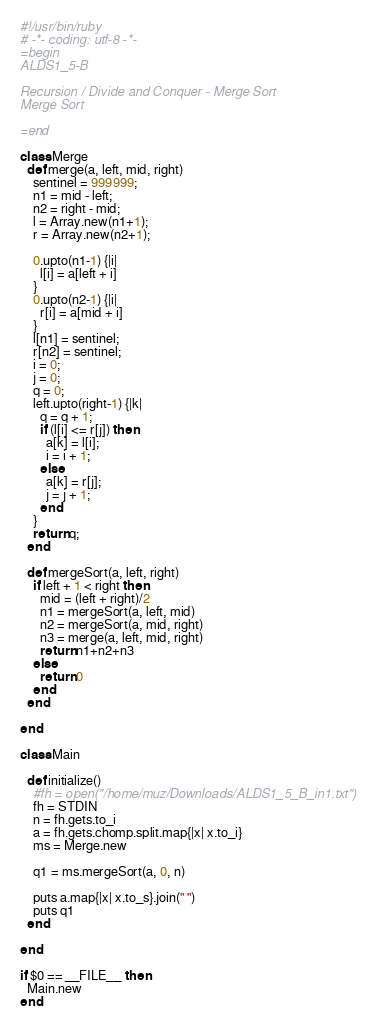Convert code to text. <code><loc_0><loc_0><loc_500><loc_500><_Ruby_>#!/usr/bin/ruby
# -*- coding: utf-8 -*-
=begin
ALDS1_5-B

Recursion / Divide and Conquer - Merge Sort
Merge Sort

=end

class Merge
  def merge(a, left, mid, right)
    sentinel = 999999;
    n1 = mid - left;
    n2 = right - mid;
    l = Array.new(n1+1);
    r = Array.new(n2+1);

    0.upto(n1-1) {|i|
      l[i] = a[left + i]
    }
    0.upto(n2-1) {|i|
      r[i] = a[mid + i]
    }
    l[n1] = sentinel;
    r[n2] = sentinel;
    i = 0;
    j = 0;
    q = 0;
    left.upto(right-1) {|k|
      q = q + 1;
      if (l[i] <= r[j]) then
        a[k] = l[i];
        i = i + 1;
      else
        a[k] = r[j];
        j = j + 1;
      end
    }
    return q;
  end

  def mergeSort(a, left, right)
    if left + 1 < right then
      mid = (left + right)/2
      n1 = mergeSort(a, left, mid)
      n2 = mergeSort(a, mid, right)
      n3 = merge(a, left, mid, right)
      return n1+n2+n3
    else
      return 0
    end
  end

end

class Main

  def initialize()
    #fh = open("/home/muz/Downloads/ALDS1_5_B_in1.txt")
    fh = STDIN
    n = fh.gets.to_i
    a = fh.gets.chomp.split.map{|x| x.to_i}
    ms = Merge.new

    q1 = ms.mergeSort(a, 0, n)

    puts a.map{|x| x.to_s}.join(" ")
    puts q1
  end

end

if $0 == __FILE__ then
  Main.new
end</code> 